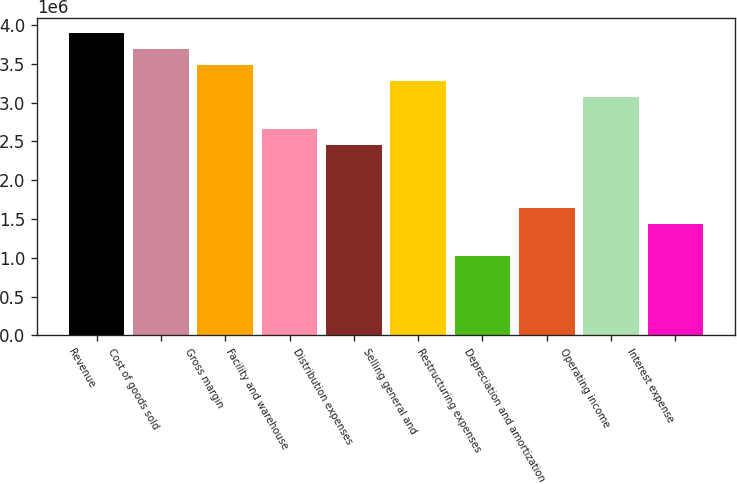Convert chart. <chart><loc_0><loc_0><loc_500><loc_500><bar_chart><fcel>Revenue<fcel>Cost of goods sold<fcel>Gross margin<fcel>Facility and warehouse<fcel>Distribution expenses<fcel>Selling general and<fcel>Restructuring expenses<fcel>Depreciation and amortization<fcel>Operating income<fcel>Interest expense<nl><fcel>3.89109e+06<fcel>3.68629e+06<fcel>3.4815e+06<fcel>2.66232e+06<fcel>2.45753e+06<fcel>3.27671e+06<fcel>1.02397e+06<fcel>1.63835e+06<fcel>3.07191e+06<fcel>1.43356e+06<nl></chart> 